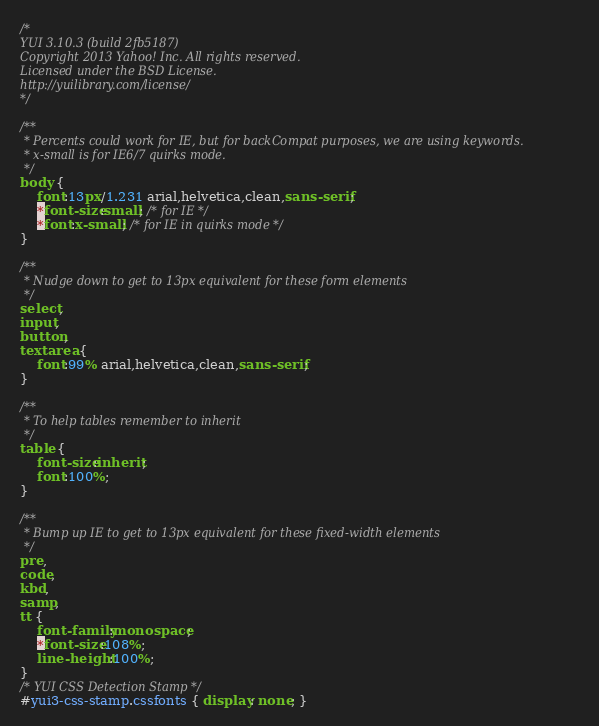<code> <loc_0><loc_0><loc_500><loc_500><_CSS_>/*
YUI 3.10.3 (build 2fb5187)
Copyright 2013 Yahoo! Inc. All rights reserved.
Licensed under the BSD License.
http://yuilibrary.com/license/
*/

/**
 * Percents could work for IE, but for backCompat purposes, we are using keywords.
 * x-small is for IE6/7 quirks mode.
 */
body {
	font:13px/1.231 arial,helvetica,clean,sans-serif;
	*font-size:small; /* for IE */
	*font:x-small; /* for IE in quirks mode */
}

/**
 * Nudge down to get to 13px equivalent for these form elements
 */ 
select,
input,
button,
textarea {
	font:99% arial,helvetica,clean,sans-serif;
}

/**
 * To help tables remember to inherit
 */
table {
	font-size:inherit;
	font:100%;
}

/**
 * Bump up IE to get to 13px equivalent for these fixed-width elements
 */
pre,
code,
kbd,
samp,
tt {
	font-family:monospace;
	*font-size:108%;
	line-height:100%;
}
/* YUI CSS Detection Stamp */
#yui3-css-stamp.cssfonts { display: none; }
</code> 